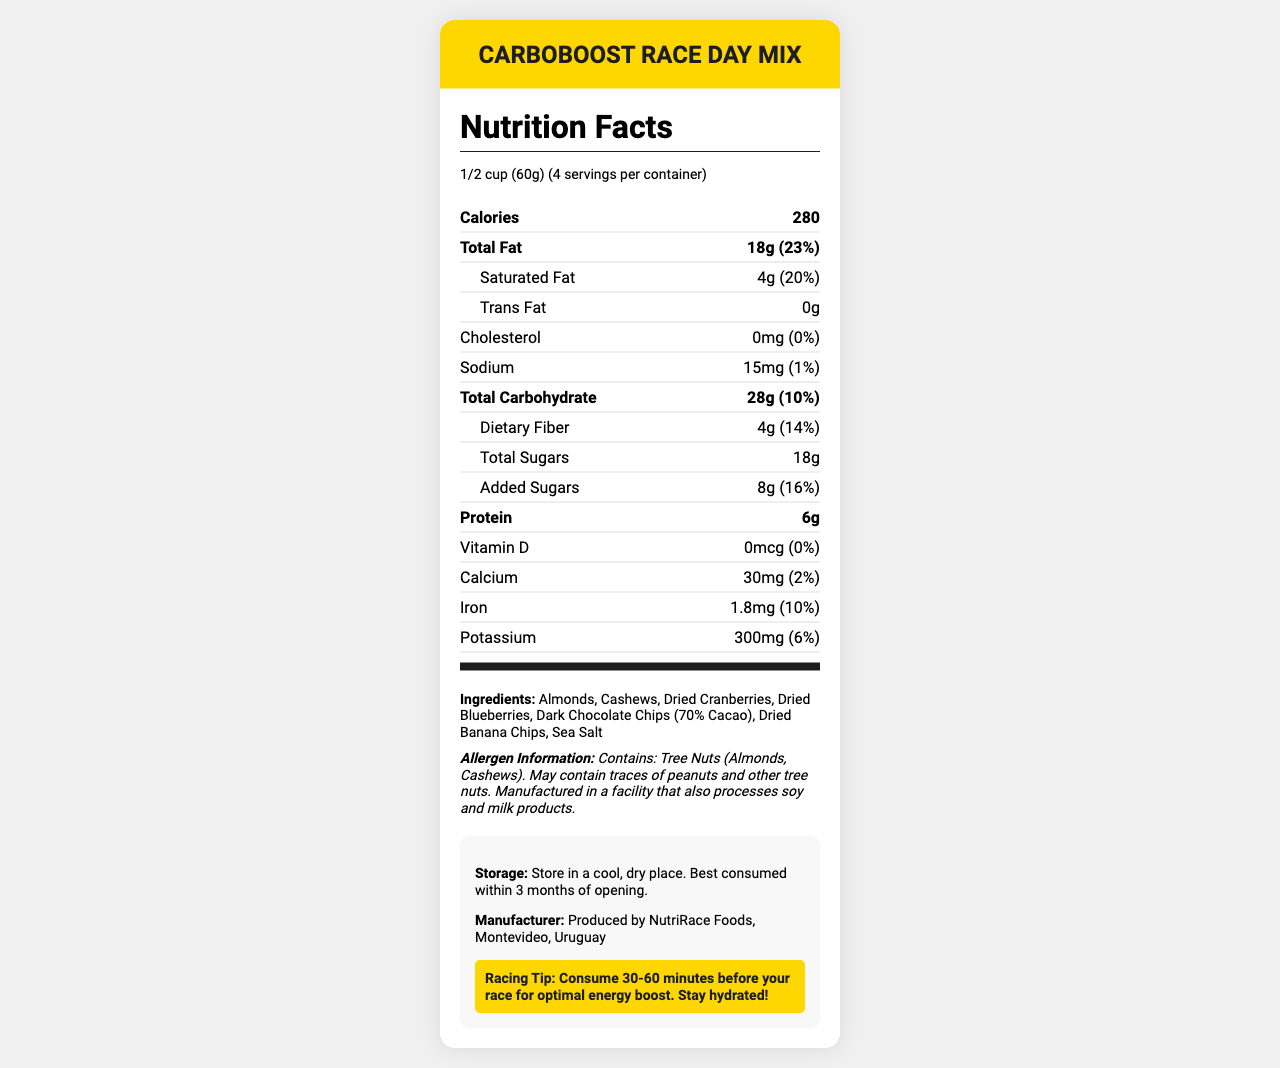what is the serving size? The serving size is clearly stated near the top of the document in the serving information section.
Answer: 1/2 cup (60g) how many calories are there per serving? The Nutrition Facts section lists the calorie count as 280 per serving.
Answer: 280 how many grams of saturated fat does one serving contain? The saturated fat amount is listed under the total fat section as 4 grams per serving.
Answer: 4g how much protein does one serving provide? The protein content is listed in the Nutrition Facts section as 6 grams per serving.
Answer: 6g what is the main idea of this document? The document includes a labeled Nutrition Facts section, ingredients list, allergen information, storage instructions, manufacturer details, and a racing tip on how to consume the product for optimal performance.
Answer: The document provides detailed nutritional information, ingredients, allergen warnings, and additional usage tips for a pre-race snack mix named CarboBoost Race Day Mix. what is the daily value percentage of iron in one serving? The daily value percentage of iron is specified in the Nutrition Facts section as 10%.
Answer: 10% how many servings are there per container? The serving information states there are 4 servings per container.
Answer: 4 which of the following contains added sugars? A. Almonds B. Cashews C. Dried Cranberries D. Sea Salt Dried cranberries typically contain added sugars, which are included in the Nutrition Facts indicating added sugars.
Answer: C how much potassium is in one serving? The potassium content is listed in the Nutrition Facts section as 300 milligrams per serving.
Answer: 300mg is the product made in Montevideo, Uruguay? The additional information section states that the product is manufactured by NutriRace Foods in Montevideo, Uruguay.
Answer: Yes what percentage of the daily value of total carbohydrates does one serving contain? The Nutrition Facts section indicates that one serving contains 10% of the daily value for total carbohydrates.
Answer: 10% how much total fat does one serving contain? The total fat content per serving is listed in the Nutrition Facts section as 18 grams.
Answer: 18g what is the allergen information for the product? The allergen information is provided towards the end of the document.
Answer: Contains: Tree Nuts (Almonds, Cashews). May contain traces of peanuts and other tree nuts. Manufactured in a facility that also processes soy and milk products. how must the product be stored after opening? A. In the refrigerator B. In a cool, dry place C. In a warm, humid place D. In direct sunlight The storage instructions in the additional information section mention storing the product in a cool, dry place.
Answer: B does this snack mix contain any cholesterol? The Nutrition Facts section indicates that there is 0 milligrams of cholesterol per serving.
Answer: No which of the following is not an ingredient in the CarboBoost Race Day Mix? A. Almonds B. Dried Cranberries C. Honey D. Dark Chocolate Chips The ingredients list does not include honey.
Answer: C what ingredients are listed in the CarboBoost Race Day Mix? The ingredients section lists all these components.
Answer: Almonds, Cashews, Dried Cranberries, Dried Blueberries, Dark Chocolate Chips (70% Cacao), Dried Banana Chips, Sea Salt what is the optimum time to consume this snack before a race for the best energy boost? The racing tip in the additional information section suggests consuming the snack 30-60 minutes before the race for optimal energy boost.
Answer: 30-60 minutes how many grams of dietary fiber does one serving contain? The dietary fiber content is listed in the Nutrition Facts section as 4 grams per serving.
Answer: 4g how many grams of total sugars does one serving contain? The total sugars content per serving is listed in the Nutrition Facts section as 18 grams.
Answer: 18g what is the difference between total sugars and added sugars per serving? The total sugars amount is 18 grams, and the added sugars amount is 8 grams, so the difference is 10 grams.
Answer: 10g can the exact manufacturing process be determined from this document? The document provides manufacturer information but does not detail the exact manufacturing process.
Answer: Not enough information 